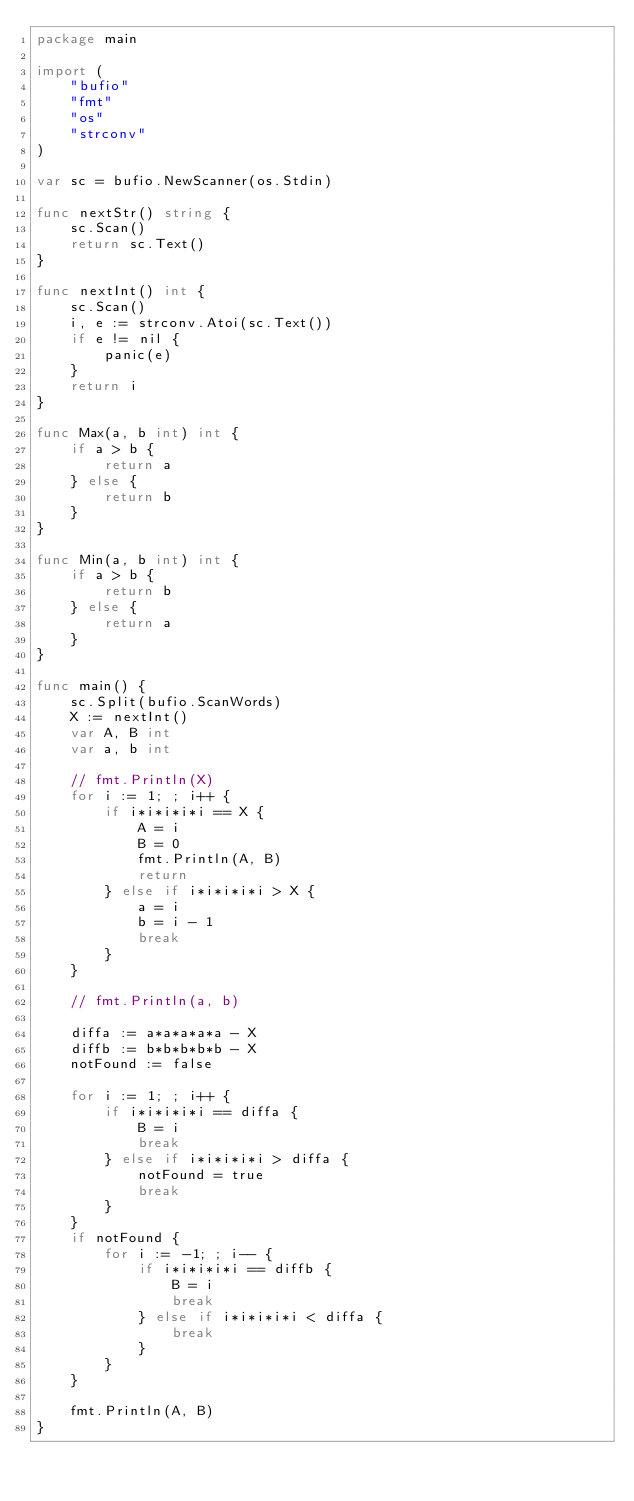Convert code to text. <code><loc_0><loc_0><loc_500><loc_500><_Go_>package main

import (
	"bufio"
	"fmt"
	"os"
	"strconv"
)

var sc = bufio.NewScanner(os.Stdin)

func nextStr() string {
	sc.Scan()
	return sc.Text()
}

func nextInt() int {
	sc.Scan()
	i, e := strconv.Atoi(sc.Text())
	if e != nil {
		panic(e)
	}
	return i
}

func Max(a, b int) int {
	if a > b {
		return a
	} else {
		return b
	}
}

func Min(a, b int) int {
	if a > b {
		return b
	} else {
		return a
	}
}

func main() {
	sc.Split(bufio.ScanWords)
	X := nextInt()
	var A, B int
	var a, b int

	// fmt.Println(X)
	for i := 1; ; i++ {
		if i*i*i*i*i == X {
			A = i
			B = 0
			fmt.Println(A, B)
			return
		} else if i*i*i*i*i > X {
			a = i
			b = i - 1
			break
		}
	}

	// fmt.Println(a, b)

	diffa := a*a*a*a*a - X
	diffb := b*b*b*b*b - X
	notFound := false

	for i := 1; ; i++ {
		if i*i*i*i*i == diffa {
			B = i
			break
		} else if i*i*i*i*i > diffa {
			notFound = true
			break
		}
	}
	if notFound {
		for i := -1; ; i-- {
			if i*i*i*i*i == diffb {
				B = i
				break
			} else if i*i*i*i*i < diffa {
				break
			}
		}
	}

	fmt.Println(A, B)
}
</code> 